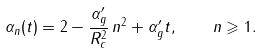Convert formula to latex. <formula><loc_0><loc_0><loc_500><loc_500>\alpha _ { n } ( t ) = 2 - \frac { \alpha _ { g } ^ { \prime } } { R _ { c } ^ { 2 } } \, n ^ { 2 } + \alpha _ { g } ^ { \prime } t , \quad n \geqslant 1 .</formula> 